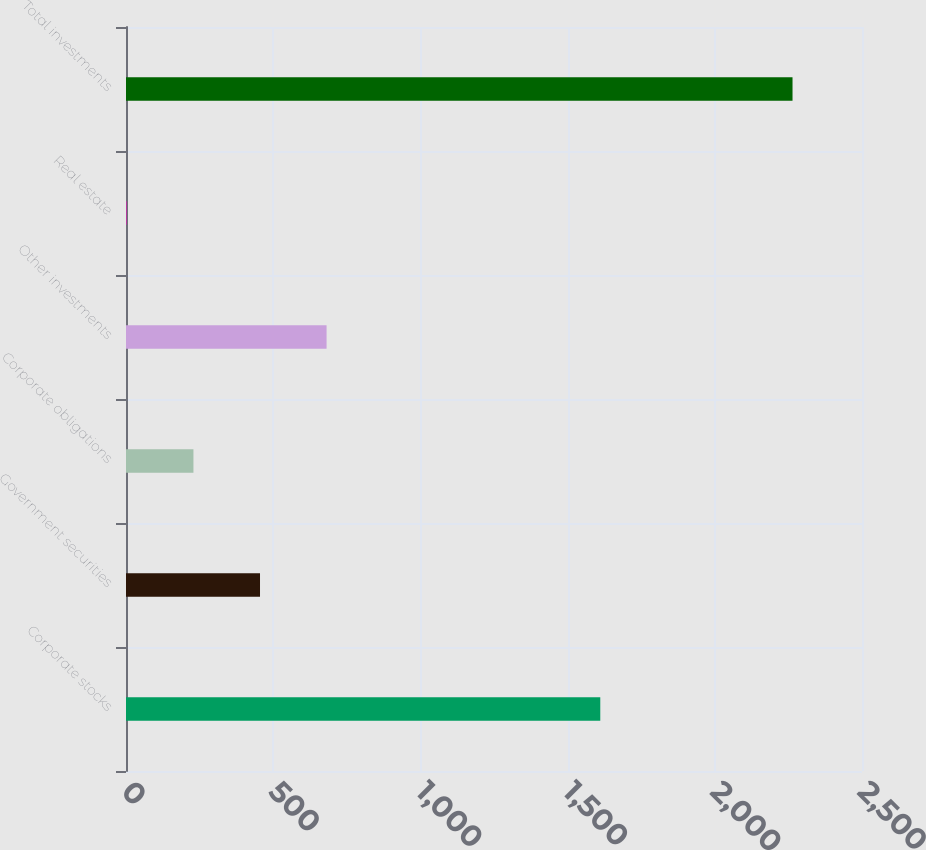<chart> <loc_0><loc_0><loc_500><loc_500><bar_chart><fcel>Corporate stocks<fcel>Government securities<fcel>Corporate obligations<fcel>Other investments<fcel>Real estate<fcel>Total investments<nl><fcel>1611<fcel>455.2<fcel>229.1<fcel>681.3<fcel>3<fcel>2264<nl></chart> 